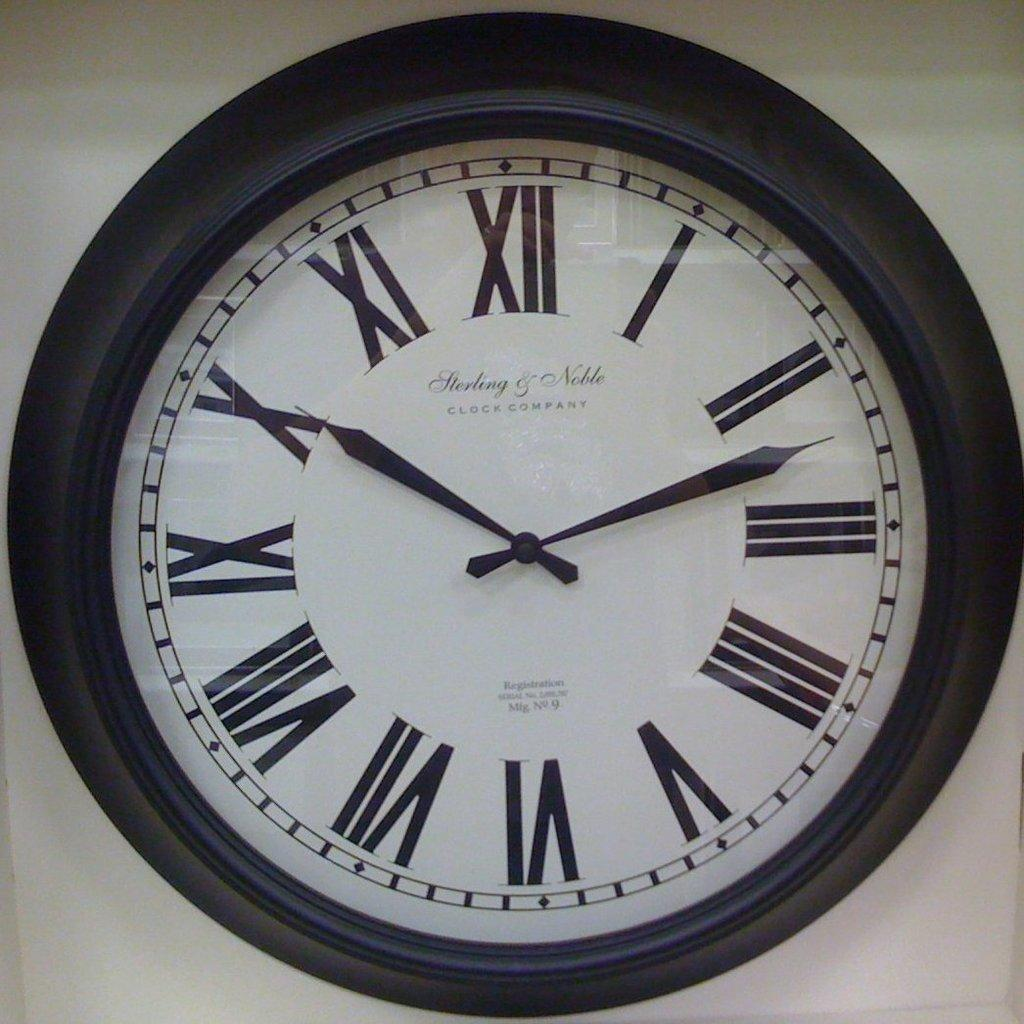<image>
Summarize the visual content of the image. White clock which says Herling and Noble on it. 